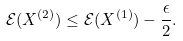<formula> <loc_0><loc_0><loc_500><loc_500>\mathcal { E } ( X ^ { ( 2 ) } ) \leq \mathcal { E } ( X ^ { ( 1 ) } ) - \frac { \epsilon } { 2 } .</formula> 